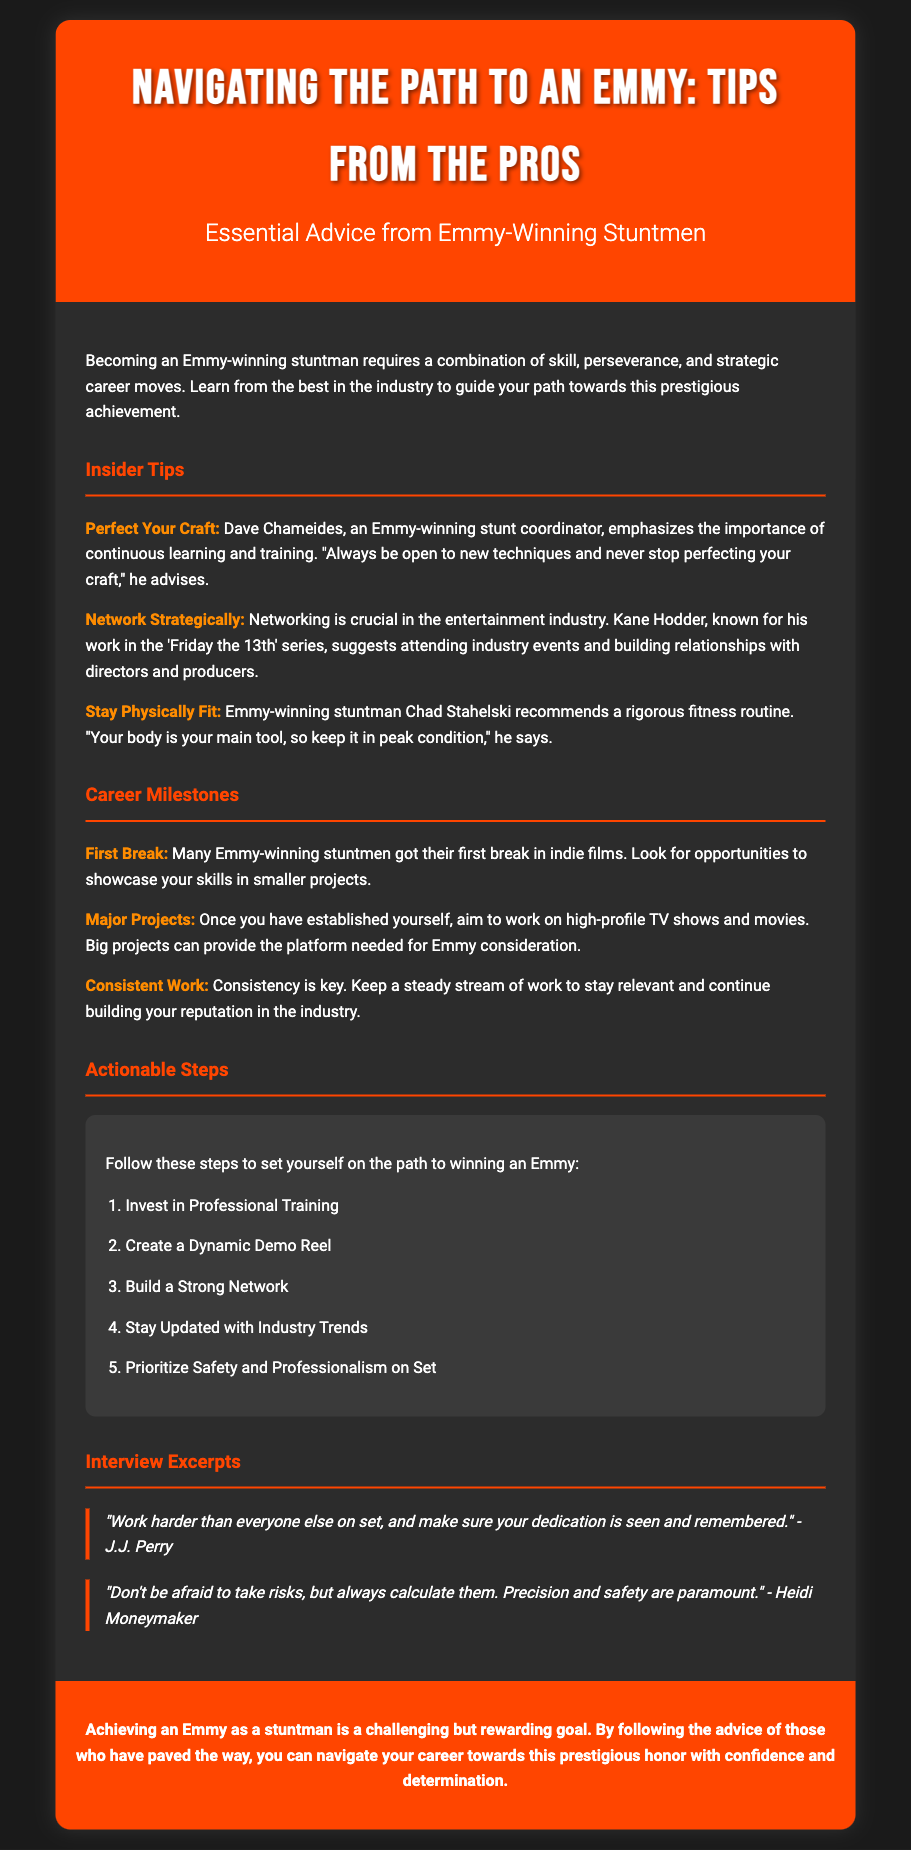what is the title of the flyer? The title is mentioned prominently at the top of the flyer.
Answer: Navigating the Path to an Emmy: Tips from the Pros who emphasizes continuous learning and training? The flyer includes specific tips from various Emmy-winning stuntmen, including their names.
Answer: Dave Chameides what should you prioritize on set according to the actionable steps? The actionable steps list specific focuses for aspiring Emmy-winning stuntmen.
Answer: Safety and Professionalism who is known for their work in the 'Friday the 13th' series? The flyer names key individuals who provided insider tips, specifying their notable works.
Answer: Kane Hodder what milestone involves working on high-profile TV shows and movies? The milestones section outlines key achievements in a stuntman's career progression.
Answer: Major Projects what is the second actionable step listed? The actionable steps are sequentially numbered in the flyer.
Answer: Create a Dynamic Demo Reel how many quotes from interviews are included in the document? The document features direct quotes as part of the content to provide insights from professionals.
Answer: Two what color scheme is used for the header? The flyer describes the visual aspects, including color choices for various sections.
Answer: Orange what is the background color of the steps section? The section background colors provide visual contrast in the document.
Answer: Dark gray 